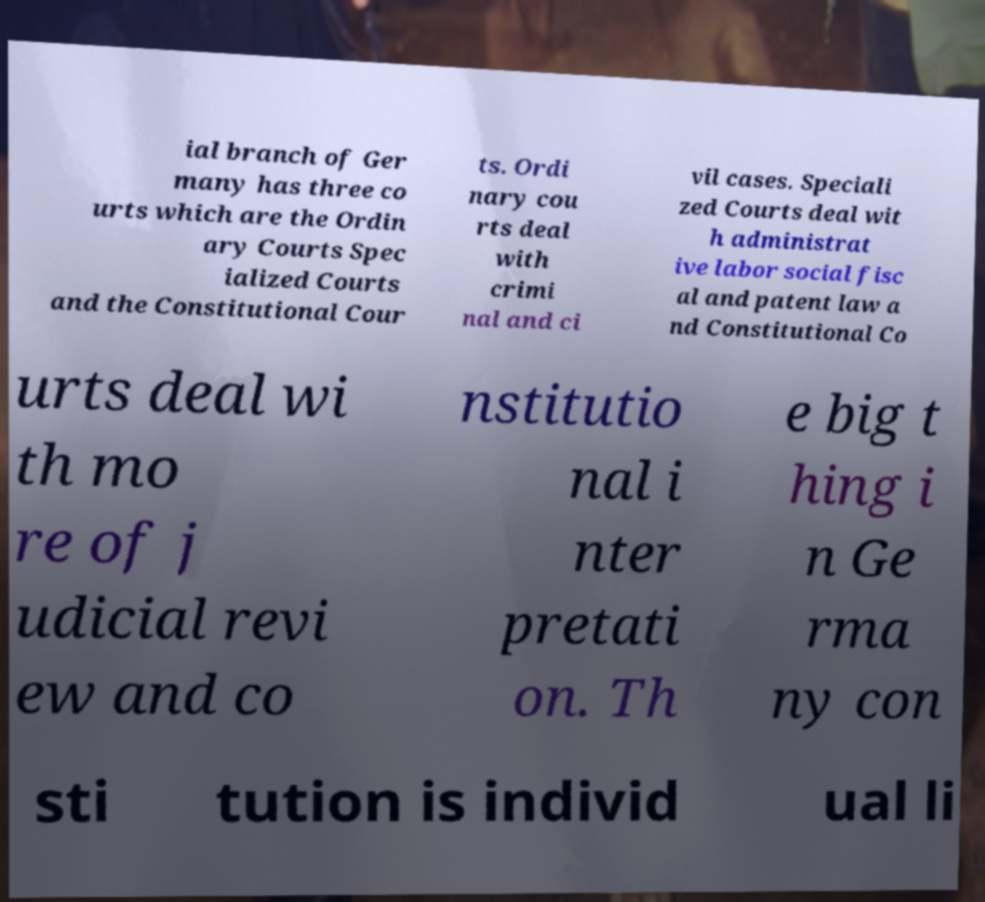Could you assist in decoding the text presented in this image and type it out clearly? ial branch of Ger many has three co urts which are the Ordin ary Courts Spec ialized Courts and the Constitutional Cour ts. Ordi nary cou rts deal with crimi nal and ci vil cases. Speciali zed Courts deal wit h administrat ive labor social fisc al and patent law a nd Constitutional Co urts deal wi th mo re of j udicial revi ew and co nstitutio nal i nter pretati on. Th e big t hing i n Ge rma ny con sti tution is individ ual li 